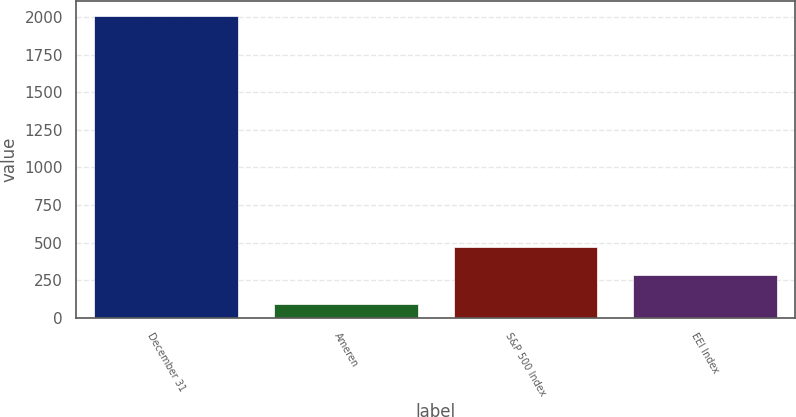Convert chart. <chart><loc_0><loc_0><loc_500><loc_500><bar_chart><fcel>December 31<fcel>Ameren<fcel>S&P 500 Index<fcel>EEI Index<nl><fcel>2009<fcel>89.29<fcel>473.23<fcel>281.26<nl></chart> 